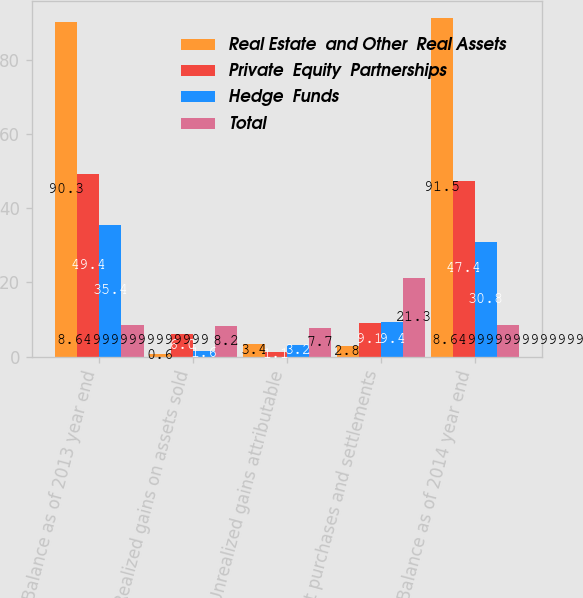<chart> <loc_0><loc_0><loc_500><loc_500><stacked_bar_chart><ecel><fcel>Balance as of 2013 year end<fcel>Realized gains on assets sold<fcel>Unrealized gains attributable<fcel>Net purchases and settlements<fcel>Balance as of 2014 year end<nl><fcel>Real Estate  and Other  Real Assets<fcel>90.3<fcel>0.6<fcel>3.4<fcel>2.8<fcel>91.5<nl><fcel>Private  Equity  Partnerships<fcel>49.4<fcel>6<fcel>1.1<fcel>9.1<fcel>47.4<nl><fcel>Hedge  Funds<fcel>35.4<fcel>1.6<fcel>3.2<fcel>9.4<fcel>30.8<nl><fcel>Total<fcel>8.65<fcel>8.2<fcel>7.7<fcel>21.3<fcel>8.65<nl></chart> 